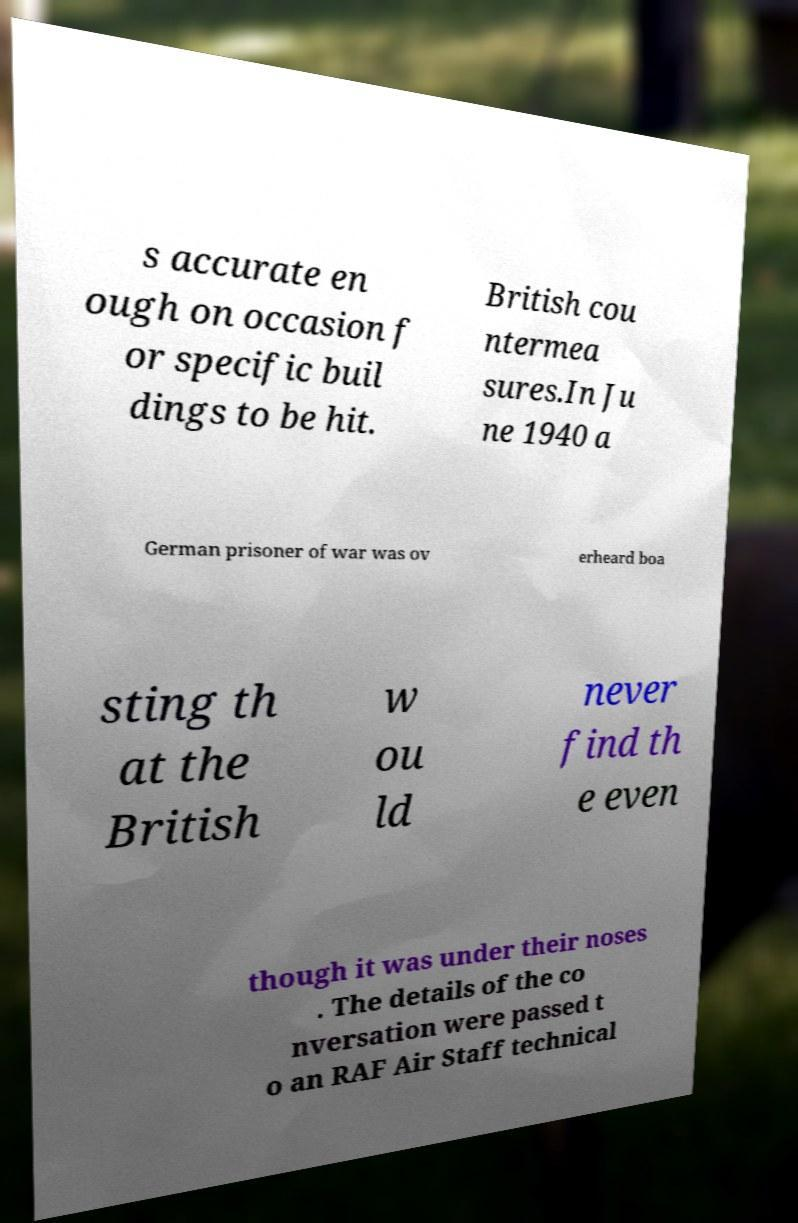Please identify and transcribe the text found in this image. s accurate en ough on occasion f or specific buil dings to be hit. British cou ntermea sures.In Ju ne 1940 a German prisoner of war was ov erheard boa sting th at the British w ou ld never find th e even though it was under their noses . The details of the co nversation were passed t o an RAF Air Staff technical 